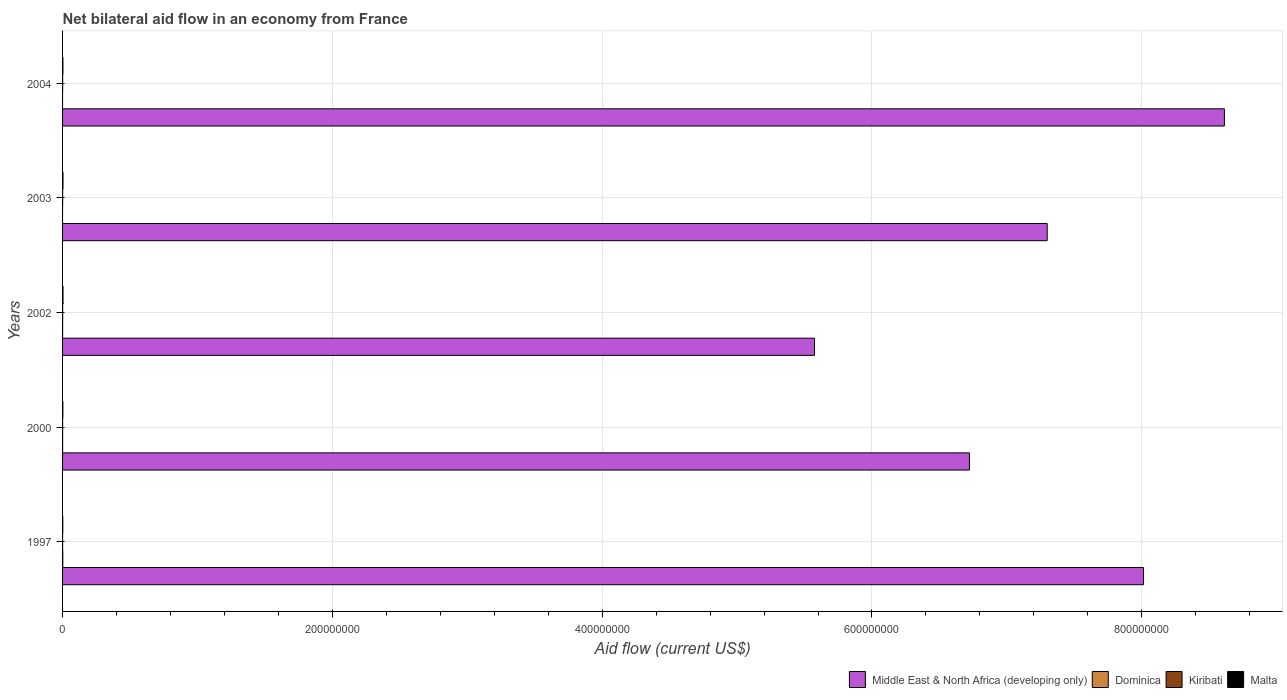How many bars are there on the 5th tick from the top?
Give a very brief answer. 4. How many bars are there on the 1st tick from the bottom?
Give a very brief answer. 4. What is the label of the 3rd group of bars from the top?
Ensure brevity in your answer.  2002. In how many cases, is the number of bars for a given year not equal to the number of legend labels?
Offer a terse response. 2. Across all years, what is the maximum net bilateral aid flow in Middle East & North Africa (developing only)?
Offer a very short reply. 8.61e+08. Across all years, what is the minimum net bilateral aid flow in Dominica?
Keep it short and to the point. 0. What is the total net bilateral aid flow in Kiribati in the graph?
Keep it short and to the point. 1.70e+05. What is the difference between the net bilateral aid flow in Kiribati in 2002 and that in 2003?
Provide a short and direct response. 2.00e+04. What is the difference between the net bilateral aid flow in Kiribati in 2004 and the net bilateral aid flow in Malta in 1997?
Ensure brevity in your answer.  -1.30e+05. What is the average net bilateral aid flow in Dominica per year?
Ensure brevity in your answer.  4.00e+04. In the year 1997, what is the difference between the net bilateral aid flow in Kiribati and net bilateral aid flow in Malta?
Provide a short and direct response. -1.60e+05. In how many years, is the net bilateral aid flow in Dominica greater than 80000000 US$?
Provide a short and direct response. 0. What is the ratio of the net bilateral aid flow in Malta in 1997 to that in 2004?
Give a very brief answer. 0.65. What is the difference between the highest and the second highest net bilateral aid flow in Malta?
Make the answer very short. 10000. What is the difference between the highest and the lowest net bilateral aid flow in Kiribati?
Give a very brief answer. 5.00e+04. Is it the case that in every year, the sum of the net bilateral aid flow in Middle East & North Africa (developing only) and net bilateral aid flow in Dominica is greater than the sum of net bilateral aid flow in Kiribati and net bilateral aid flow in Malta?
Offer a very short reply. Yes. How many bars are there?
Provide a succinct answer. 18. Are all the bars in the graph horizontal?
Your answer should be compact. Yes. What is the difference between two consecutive major ticks on the X-axis?
Make the answer very short. 2.00e+08. Are the values on the major ticks of X-axis written in scientific E-notation?
Your answer should be compact. No. Does the graph contain any zero values?
Make the answer very short. Yes. How are the legend labels stacked?
Keep it short and to the point. Horizontal. What is the title of the graph?
Provide a short and direct response. Net bilateral aid flow in an economy from France. What is the label or title of the Y-axis?
Provide a short and direct response. Years. What is the Aid flow (current US$) of Middle East & North Africa (developing only) in 1997?
Offer a terse response. 8.01e+08. What is the Aid flow (current US$) in Dominica in 1997?
Ensure brevity in your answer.  1.50e+05. What is the Aid flow (current US$) in Malta in 1997?
Offer a terse response. 1.70e+05. What is the Aid flow (current US$) in Middle East & North Africa (developing only) in 2000?
Ensure brevity in your answer.  6.72e+08. What is the Aid flow (current US$) of Kiribati in 2000?
Provide a short and direct response. 2.00e+04. What is the Aid flow (current US$) of Malta in 2000?
Keep it short and to the point. 2.20e+05. What is the Aid flow (current US$) of Middle East & North Africa (developing only) in 2002?
Offer a very short reply. 5.57e+08. What is the Aid flow (current US$) in Dominica in 2002?
Provide a short and direct response. 2.00e+04. What is the Aid flow (current US$) in Middle East & North Africa (developing only) in 2003?
Make the answer very short. 7.30e+08. What is the Aid flow (current US$) in Malta in 2003?
Ensure brevity in your answer.  3.20e+05. What is the Aid flow (current US$) in Middle East & North Africa (developing only) in 2004?
Give a very brief answer. 8.61e+08. What is the Aid flow (current US$) in Kiribati in 2004?
Provide a short and direct response. 4.00e+04. Across all years, what is the maximum Aid flow (current US$) of Middle East & North Africa (developing only)?
Keep it short and to the point. 8.61e+08. Across all years, what is the maximum Aid flow (current US$) in Dominica?
Make the answer very short. 1.50e+05. Across all years, what is the minimum Aid flow (current US$) of Middle East & North Africa (developing only)?
Your answer should be compact. 5.57e+08. Across all years, what is the minimum Aid flow (current US$) of Dominica?
Keep it short and to the point. 0. Across all years, what is the minimum Aid flow (current US$) in Kiribati?
Provide a short and direct response. 10000. What is the total Aid flow (current US$) in Middle East & North Africa (developing only) in the graph?
Your response must be concise. 3.62e+09. What is the total Aid flow (current US$) of Dominica in the graph?
Give a very brief answer. 2.00e+05. What is the total Aid flow (current US$) in Kiribati in the graph?
Offer a terse response. 1.70e+05. What is the total Aid flow (current US$) in Malta in the graph?
Your answer should be very brief. 1.30e+06. What is the difference between the Aid flow (current US$) of Middle East & North Africa (developing only) in 1997 and that in 2000?
Offer a terse response. 1.29e+08. What is the difference between the Aid flow (current US$) in Middle East & North Africa (developing only) in 1997 and that in 2002?
Give a very brief answer. 2.44e+08. What is the difference between the Aid flow (current US$) in Dominica in 1997 and that in 2002?
Your answer should be compact. 1.30e+05. What is the difference between the Aid flow (current US$) of Kiribati in 1997 and that in 2002?
Your response must be concise. -5.00e+04. What is the difference between the Aid flow (current US$) of Malta in 1997 and that in 2002?
Your response must be concise. -1.60e+05. What is the difference between the Aid flow (current US$) of Middle East & North Africa (developing only) in 1997 and that in 2003?
Provide a short and direct response. 7.14e+07. What is the difference between the Aid flow (current US$) of Malta in 1997 and that in 2003?
Ensure brevity in your answer.  -1.50e+05. What is the difference between the Aid flow (current US$) of Middle East & North Africa (developing only) in 1997 and that in 2004?
Your answer should be compact. -6.00e+07. What is the difference between the Aid flow (current US$) in Kiribati in 1997 and that in 2004?
Offer a very short reply. -3.00e+04. What is the difference between the Aid flow (current US$) of Middle East & North Africa (developing only) in 2000 and that in 2002?
Offer a very short reply. 1.15e+08. What is the difference between the Aid flow (current US$) of Dominica in 2000 and that in 2002?
Provide a short and direct response. 10000. What is the difference between the Aid flow (current US$) of Malta in 2000 and that in 2002?
Make the answer very short. -1.10e+05. What is the difference between the Aid flow (current US$) of Middle East & North Africa (developing only) in 2000 and that in 2003?
Your response must be concise. -5.76e+07. What is the difference between the Aid flow (current US$) in Kiribati in 2000 and that in 2003?
Your answer should be compact. -2.00e+04. What is the difference between the Aid flow (current US$) of Middle East & North Africa (developing only) in 2000 and that in 2004?
Your answer should be compact. -1.89e+08. What is the difference between the Aid flow (current US$) of Kiribati in 2000 and that in 2004?
Provide a succinct answer. -2.00e+04. What is the difference between the Aid flow (current US$) of Middle East & North Africa (developing only) in 2002 and that in 2003?
Make the answer very short. -1.73e+08. What is the difference between the Aid flow (current US$) in Middle East & North Africa (developing only) in 2002 and that in 2004?
Give a very brief answer. -3.04e+08. What is the difference between the Aid flow (current US$) in Malta in 2002 and that in 2004?
Give a very brief answer. 7.00e+04. What is the difference between the Aid flow (current US$) in Middle East & North Africa (developing only) in 2003 and that in 2004?
Keep it short and to the point. -1.31e+08. What is the difference between the Aid flow (current US$) in Middle East & North Africa (developing only) in 1997 and the Aid flow (current US$) in Dominica in 2000?
Your response must be concise. 8.01e+08. What is the difference between the Aid flow (current US$) in Middle East & North Africa (developing only) in 1997 and the Aid flow (current US$) in Kiribati in 2000?
Your answer should be very brief. 8.01e+08. What is the difference between the Aid flow (current US$) of Middle East & North Africa (developing only) in 1997 and the Aid flow (current US$) of Malta in 2000?
Offer a terse response. 8.01e+08. What is the difference between the Aid flow (current US$) in Dominica in 1997 and the Aid flow (current US$) in Kiribati in 2000?
Make the answer very short. 1.30e+05. What is the difference between the Aid flow (current US$) in Middle East & North Africa (developing only) in 1997 and the Aid flow (current US$) in Dominica in 2002?
Your answer should be very brief. 8.01e+08. What is the difference between the Aid flow (current US$) of Middle East & North Africa (developing only) in 1997 and the Aid flow (current US$) of Kiribati in 2002?
Ensure brevity in your answer.  8.01e+08. What is the difference between the Aid flow (current US$) of Middle East & North Africa (developing only) in 1997 and the Aid flow (current US$) of Malta in 2002?
Make the answer very short. 8.01e+08. What is the difference between the Aid flow (current US$) in Dominica in 1997 and the Aid flow (current US$) in Malta in 2002?
Ensure brevity in your answer.  -1.80e+05. What is the difference between the Aid flow (current US$) of Kiribati in 1997 and the Aid flow (current US$) of Malta in 2002?
Offer a terse response. -3.20e+05. What is the difference between the Aid flow (current US$) in Middle East & North Africa (developing only) in 1997 and the Aid flow (current US$) in Kiribati in 2003?
Your response must be concise. 8.01e+08. What is the difference between the Aid flow (current US$) of Middle East & North Africa (developing only) in 1997 and the Aid flow (current US$) of Malta in 2003?
Your response must be concise. 8.01e+08. What is the difference between the Aid flow (current US$) in Kiribati in 1997 and the Aid flow (current US$) in Malta in 2003?
Ensure brevity in your answer.  -3.10e+05. What is the difference between the Aid flow (current US$) of Middle East & North Africa (developing only) in 1997 and the Aid flow (current US$) of Kiribati in 2004?
Make the answer very short. 8.01e+08. What is the difference between the Aid flow (current US$) of Middle East & North Africa (developing only) in 1997 and the Aid flow (current US$) of Malta in 2004?
Your answer should be compact. 8.01e+08. What is the difference between the Aid flow (current US$) of Dominica in 1997 and the Aid flow (current US$) of Kiribati in 2004?
Make the answer very short. 1.10e+05. What is the difference between the Aid flow (current US$) of Middle East & North Africa (developing only) in 2000 and the Aid flow (current US$) of Dominica in 2002?
Keep it short and to the point. 6.72e+08. What is the difference between the Aid flow (current US$) in Middle East & North Africa (developing only) in 2000 and the Aid flow (current US$) in Kiribati in 2002?
Keep it short and to the point. 6.72e+08. What is the difference between the Aid flow (current US$) of Middle East & North Africa (developing only) in 2000 and the Aid flow (current US$) of Malta in 2002?
Offer a very short reply. 6.72e+08. What is the difference between the Aid flow (current US$) in Dominica in 2000 and the Aid flow (current US$) in Kiribati in 2002?
Your answer should be compact. -3.00e+04. What is the difference between the Aid flow (current US$) in Kiribati in 2000 and the Aid flow (current US$) in Malta in 2002?
Offer a terse response. -3.10e+05. What is the difference between the Aid flow (current US$) of Middle East & North Africa (developing only) in 2000 and the Aid flow (current US$) of Kiribati in 2003?
Offer a very short reply. 6.72e+08. What is the difference between the Aid flow (current US$) in Middle East & North Africa (developing only) in 2000 and the Aid flow (current US$) in Malta in 2003?
Ensure brevity in your answer.  6.72e+08. What is the difference between the Aid flow (current US$) in Dominica in 2000 and the Aid flow (current US$) in Kiribati in 2003?
Ensure brevity in your answer.  -10000. What is the difference between the Aid flow (current US$) of Kiribati in 2000 and the Aid flow (current US$) of Malta in 2003?
Give a very brief answer. -3.00e+05. What is the difference between the Aid flow (current US$) of Middle East & North Africa (developing only) in 2000 and the Aid flow (current US$) of Kiribati in 2004?
Offer a very short reply. 6.72e+08. What is the difference between the Aid flow (current US$) in Middle East & North Africa (developing only) in 2000 and the Aid flow (current US$) in Malta in 2004?
Your response must be concise. 6.72e+08. What is the difference between the Aid flow (current US$) in Dominica in 2000 and the Aid flow (current US$) in Kiribati in 2004?
Your answer should be compact. -10000. What is the difference between the Aid flow (current US$) in Dominica in 2000 and the Aid flow (current US$) in Malta in 2004?
Provide a short and direct response. -2.30e+05. What is the difference between the Aid flow (current US$) of Middle East & North Africa (developing only) in 2002 and the Aid flow (current US$) of Kiribati in 2003?
Your answer should be very brief. 5.57e+08. What is the difference between the Aid flow (current US$) of Middle East & North Africa (developing only) in 2002 and the Aid flow (current US$) of Malta in 2003?
Offer a terse response. 5.57e+08. What is the difference between the Aid flow (current US$) of Kiribati in 2002 and the Aid flow (current US$) of Malta in 2003?
Provide a succinct answer. -2.60e+05. What is the difference between the Aid flow (current US$) of Middle East & North Africa (developing only) in 2002 and the Aid flow (current US$) of Kiribati in 2004?
Provide a succinct answer. 5.57e+08. What is the difference between the Aid flow (current US$) in Middle East & North Africa (developing only) in 2002 and the Aid flow (current US$) in Malta in 2004?
Provide a short and direct response. 5.57e+08. What is the difference between the Aid flow (current US$) in Kiribati in 2002 and the Aid flow (current US$) in Malta in 2004?
Your answer should be very brief. -2.00e+05. What is the difference between the Aid flow (current US$) in Middle East & North Africa (developing only) in 2003 and the Aid flow (current US$) in Kiribati in 2004?
Your answer should be very brief. 7.30e+08. What is the difference between the Aid flow (current US$) of Middle East & North Africa (developing only) in 2003 and the Aid flow (current US$) of Malta in 2004?
Your response must be concise. 7.30e+08. What is the average Aid flow (current US$) of Middle East & North Africa (developing only) per year?
Make the answer very short. 7.24e+08. What is the average Aid flow (current US$) in Dominica per year?
Offer a terse response. 4.00e+04. What is the average Aid flow (current US$) of Kiribati per year?
Give a very brief answer. 3.40e+04. In the year 1997, what is the difference between the Aid flow (current US$) of Middle East & North Africa (developing only) and Aid flow (current US$) of Dominica?
Provide a succinct answer. 8.01e+08. In the year 1997, what is the difference between the Aid flow (current US$) in Middle East & North Africa (developing only) and Aid flow (current US$) in Kiribati?
Your answer should be very brief. 8.01e+08. In the year 1997, what is the difference between the Aid flow (current US$) in Middle East & North Africa (developing only) and Aid flow (current US$) in Malta?
Give a very brief answer. 8.01e+08. In the year 1997, what is the difference between the Aid flow (current US$) of Dominica and Aid flow (current US$) of Kiribati?
Provide a succinct answer. 1.40e+05. In the year 1997, what is the difference between the Aid flow (current US$) of Kiribati and Aid flow (current US$) of Malta?
Offer a very short reply. -1.60e+05. In the year 2000, what is the difference between the Aid flow (current US$) of Middle East & North Africa (developing only) and Aid flow (current US$) of Dominica?
Your answer should be compact. 6.72e+08. In the year 2000, what is the difference between the Aid flow (current US$) of Middle East & North Africa (developing only) and Aid flow (current US$) of Kiribati?
Your response must be concise. 6.72e+08. In the year 2000, what is the difference between the Aid flow (current US$) in Middle East & North Africa (developing only) and Aid flow (current US$) in Malta?
Your response must be concise. 6.72e+08. In the year 2000, what is the difference between the Aid flow (current US$) of Dominica and Aid flow (current US$) of Malta?
Keep it short and to the point. -1.90e+05. In the year 2002, what is the difference between the Aid flow (current US$) of Middle East & North Africa (developing only) and Aid flow (current US$) of Dominica?
Your answer should be very brief. 5.57e+08. In the year 2002, what is the difference between the Aid flow (current US$) of Middle East & North Africa (developing only) and Aid flow (current US$) of Kiribati?
Your response must be concise. 5.57e+08. In the year 2002, what is the difference between the Aid flow (current US$) of Middle East & North Africa (developing only) and Aid flow (current US$) of Malta?
Give a very brief answer. 5.57e+08. In the year 2002, what is the difference between the Aid flow (current US$) of Dominica and Aid flow (current US$) of Malta?
Make the answer very short. -3.10e+05. In the year 2003, what is the difference between the Aid flow (current US$) of Middle East & North Africa (developing only) and Aid flow (current US$) of Kiribati?
Make the answer very short. 7.30e+08. In the year 2003, what is the difference between the Aid flow (current US$) in Middle East & North Africa (developing only) and Aid flow (current US$) in Malta?
Give a very brief answer. 7.30e+08. In the year 2003, what is the difference between the Aid flow (current US$) in Kiribati and Aid flow (current US$) in Malta?
Make the answer very short. -2.80e+05. In the year 2004, what is the difference between the Aid flow (current US$) of Middle East & North Africa (developing only) and Aid flow (current US$) of Kiribati?
Your answer should be compact. 8.61e+08. In the year 2004, what is the difference between the Aid flow (current US$) in Middle East & North Africa (developing only) and Aid flow (current US$) in Malta?
Ensure brevity in your answer.  8.61e+08. What is the ratio of the Aid flow (current US$) of Middle East & North Africa (developing only) in 1997 to that in 2000?
Your answer should be very brief. 1.19. What is the ratio of the Aid flow (current US$) in Kiribati in 1997 to that in 2000?
Your answer should be very brief. 0.5. What is the ratio of the Aid flow (current US$) of Malta in 1997 to that in 2000?
Your answer should be very brief. 0.77. What is the ratio of the Aid flow (current US$) of Middle East & North Africa (developing only) in 1997 to that in 2002?
Offer a terse response. 1.44. What is the ratio of the Aid flow (current US$) of Malta in 1997 to that in 2002?
Offer a terse response. 0.52. What is the ratio of the Aid flow (current US$) in Middle East & North Africa (developing only) in 1997 to that in 2003?
Offer a terse response. 1.1. What is the ratio of the Aid flow (current US$) of Malta in 1997 to that in 2003?
Give a very brief answer. 0.53. What is the ratio of the Aid flow (current US$) of Middle East & North Africa (developing only) in 1997 to that in 2004?
Give a very brief answer. 0.93. What is the ratio of the Aid flow (current US$) of Kiribati in 1997 to that in 2004?
Offer a very short reply. 0.25. What is the ratio of the Aid flow (current US$) in Malta in 1997 to that in 2004?
Offer a terse response. 0.65. What is the ratio of the Aid flow (current US$) of Middle East & North Africa (developing only) in 2000 to that in 2002?
Give a very brief answer. 1.21. What is the ratio of the Aid flow (current US$) of Middle East & North Africa (developing only) in 2000 to that in 2003?
Provide a short and direct response. 0.92. What is the ratio of the Aid flow (current US$) of Kiribati in 2000 to that in 2003?
Ensure brevity in your answer.  0.5. What is the ratio of the Aid flow (current US$) of Malta in 2000 to that in 2003?
Provide a short and direct response. 0.69. What is the ratio of the Aid flow (current US$) of Middle East & North Africa (developing only) in 2000 to that in 2004?
Make the answer very short. 0.78. What is the ratio of the Aid flow (current US$) in Kiribati in 2000 to that in 2004?
Your answer should be very brief. 0.5. What is the ratio of the Aid flow (current US$) in Malta in 2000 to that in 2004?
Your answer should be very brief. 0.85. What is the ratio of the Aid flow (current US$) of Middle East & North Africa (developing only) in 2002 to that in 2003?
Give a very brief answer. 0.76. What is the ratio of the Aid flow (current US$) in Malta in 2002 to that in 2003?
Your answer should be very brief. 1.03. What is the ratio of the Aid flow (current US$) of Middle East & North Africa (developing only) in 2002 to that in 2004?
Ensure brevity in your answer.  0.65. What is the ratio of the Aid flow (current US$) in Malta in 2002 to that in 2004?
Your response must be concise. 1.27. What is the ratio of the Aid flow (current US$) of Middle East & North Africa (developing only) in 2003 to that in 2004?
Your answer should be compact. 0.85. What is the ratio of the Aid flow (current US$) of Malta in 2003 to that in 2004?
Ensure brevity in your answer.  1.23. What is the difference between the highest and the second highest Aid flow (current US$) of Middle East & North Africa (developing only)?
Ensure brevity in your answer.  6.00e+07. What is the difference between the highest and the second highest Aid flow (current US$) in Dominica?
Offer a terse response. 1.20e+05. What is the difference between the highest and the second highest Aid flow (current US$) of Malta?
Give a very brief answer. 10000. What is the difference between the highest and the lowest Aid flow (current US$) of Middle East & North Africa (developing only)?
Your answer should be very brief. 3.04e+08. What is the difference between the highest and the lowest Aid flow (current US$) in Dominica?
Offer a very short reply. 1.50e+05. What is the difference between the highest and the lowest Aid flow (current US$) in Malta?
Make the answer very short. 1.60e+05. 